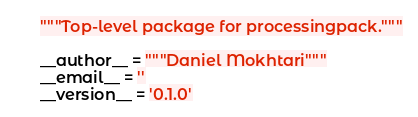<code> <loc_0><loc_0><loc_500><loc_500><_Python_>"""Top-level package for processingpack."""

__author__ = """Daniel Mokhtari"""
__email__ = ''
__version__ = '0.1.0'
</code> 